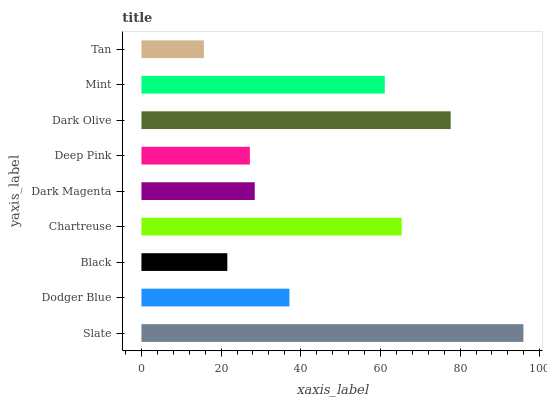Is Tan the minimum?
Answer yes or no. Yes. Is Slate the maximum?
Answer yes or no. Yes. Is Dodger Blue the minimum?
Answer yes or no. No. Is Dodger Blue the maximum?
Answer yes or no. No. Is Slate greater than Dodger Blue?
Answer yes or no. Yes. Is Dodger Blue less than Slate?
Answer yes or no. Yes. Is Dodger Blue greater than Slate?
Answer yes or no. No. Is Slate less than Dodger Blue?
Answer yes or no. No. Is Dodger Blue the high median?
Answer yes or no. Yes. Is Dodger Blue the low median?
Answer yes or no. Yes. Is Chartreuse the high median?
Answer yes or no. No. Is Deep Pink the low median?
Answer yes or no. No. 